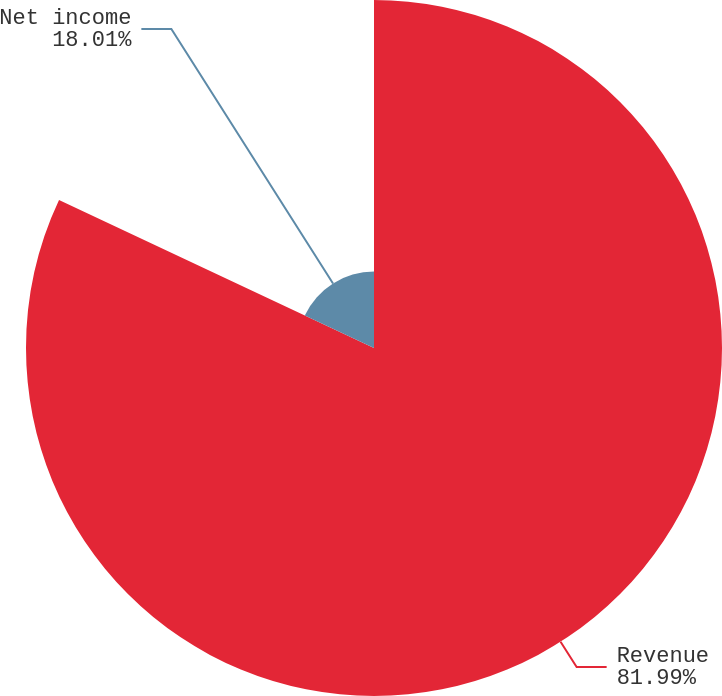<chart> <loc_0><loc_0><loc_500><loc_500><pie_chart><fcel>Revenue<fcel>Net income<nl><fcel>81.99%<fcel>18.01%<nl></chart> 